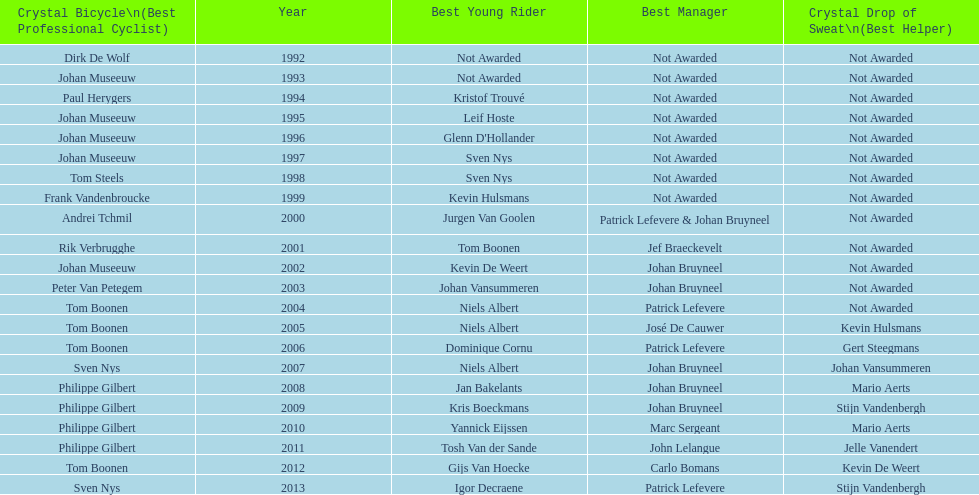What is the average number of times johan museeuw starred? 5. 